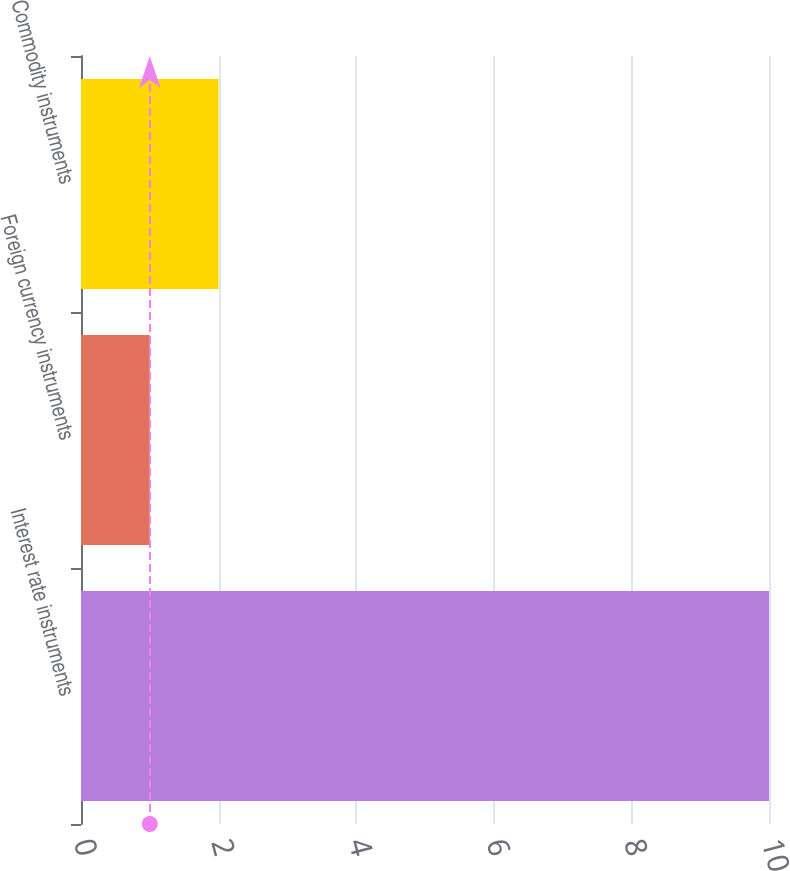Convert chart. <chart><loc_0><loc_0><loc_500><loc_500><bar_chart><fcel>Interest rate instruments<fcel>Foreign currency instruments<fcel>Commodity instruments<nl><fcel>10<fcel>1<fcel>2<nl></chart> 